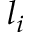<formula> <loc_0><loc_0><loc_500><loc_500>l _ { i }</formula> 